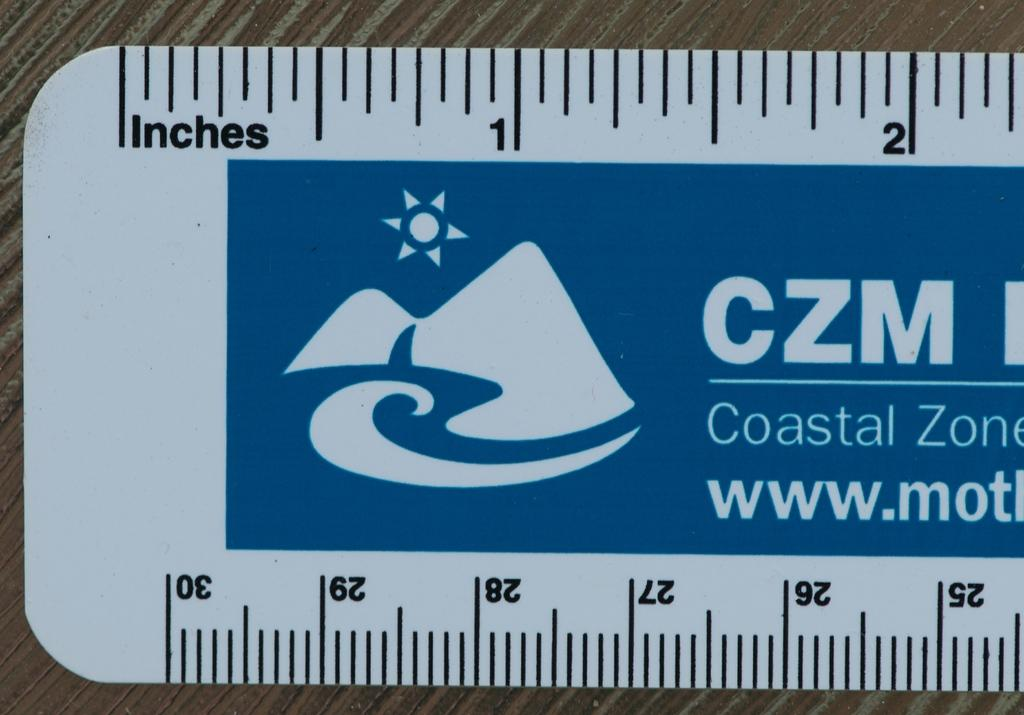Provide a one-sentence caption for the provided image. a rulers in inches and centimeters from the coastal zone. 